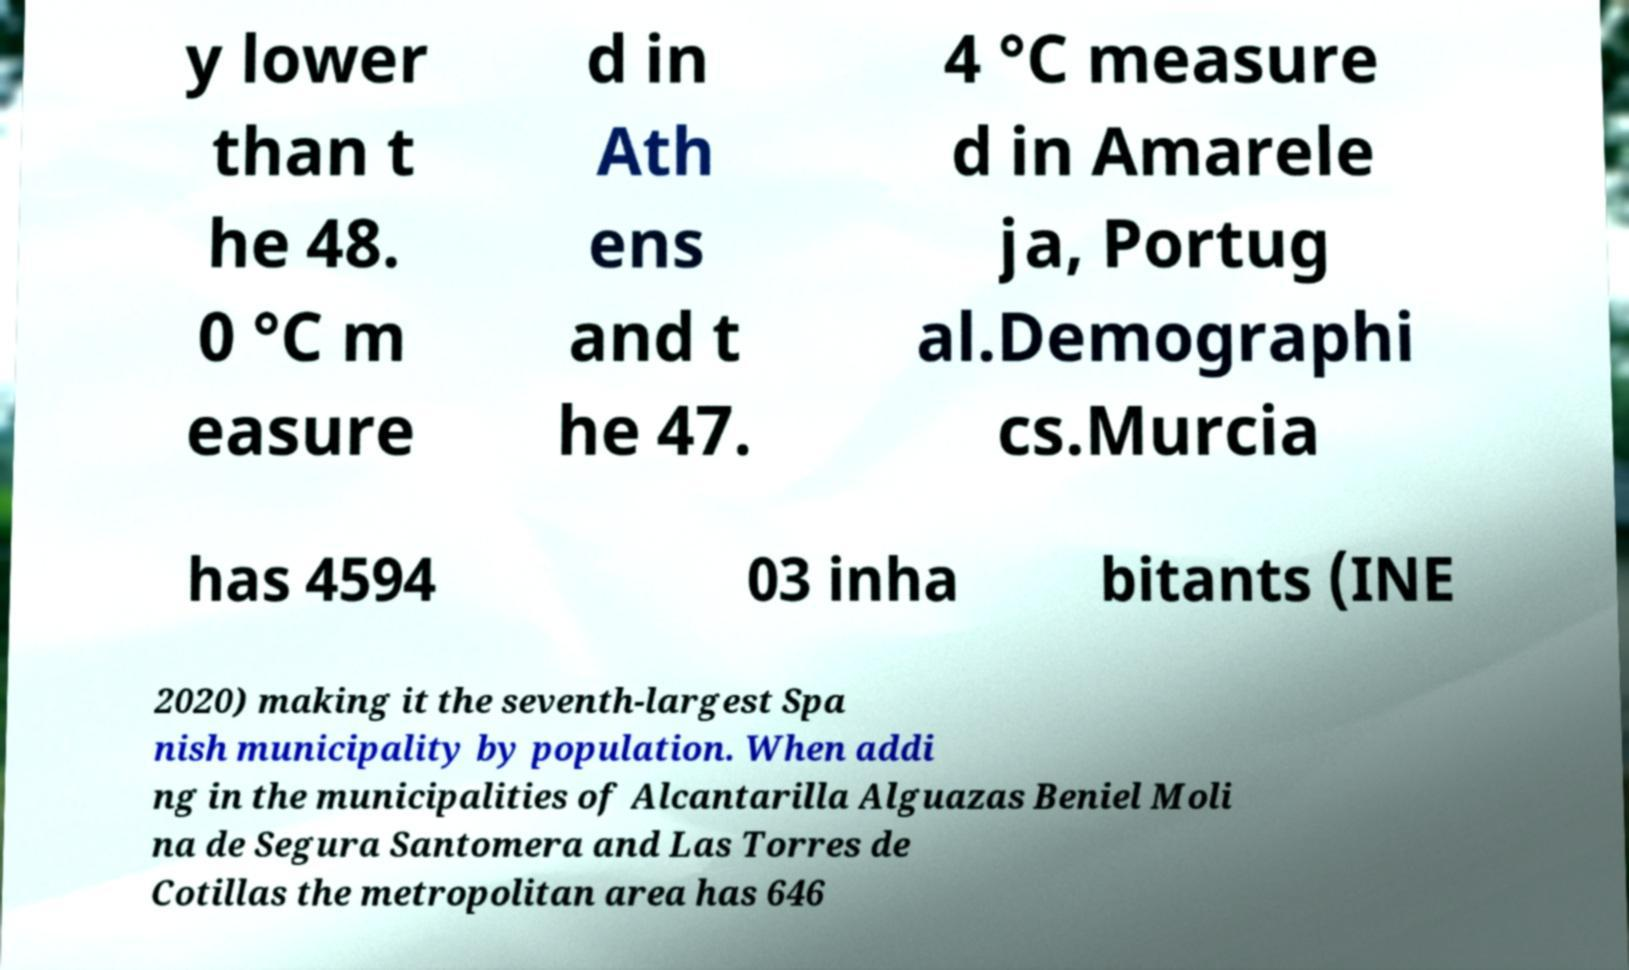What messages or text are displayed in this image? I need them in a readable, typed format. y lower than t he 48. 0 °C m easure d in Ath ens and t he 47. 4 °C measure d in Amarele ja, Portug al.Demographi cs.Murcia has 4594 03 inha bitants (INE 2020) making it the seventh-largest Spa nish municipality by population. When addi ng in the municipalities of Alcantarilla Alguazas Beniel Moli na de Segura Santomera and Las Torres de Cotillas the metropolitan area has 646 